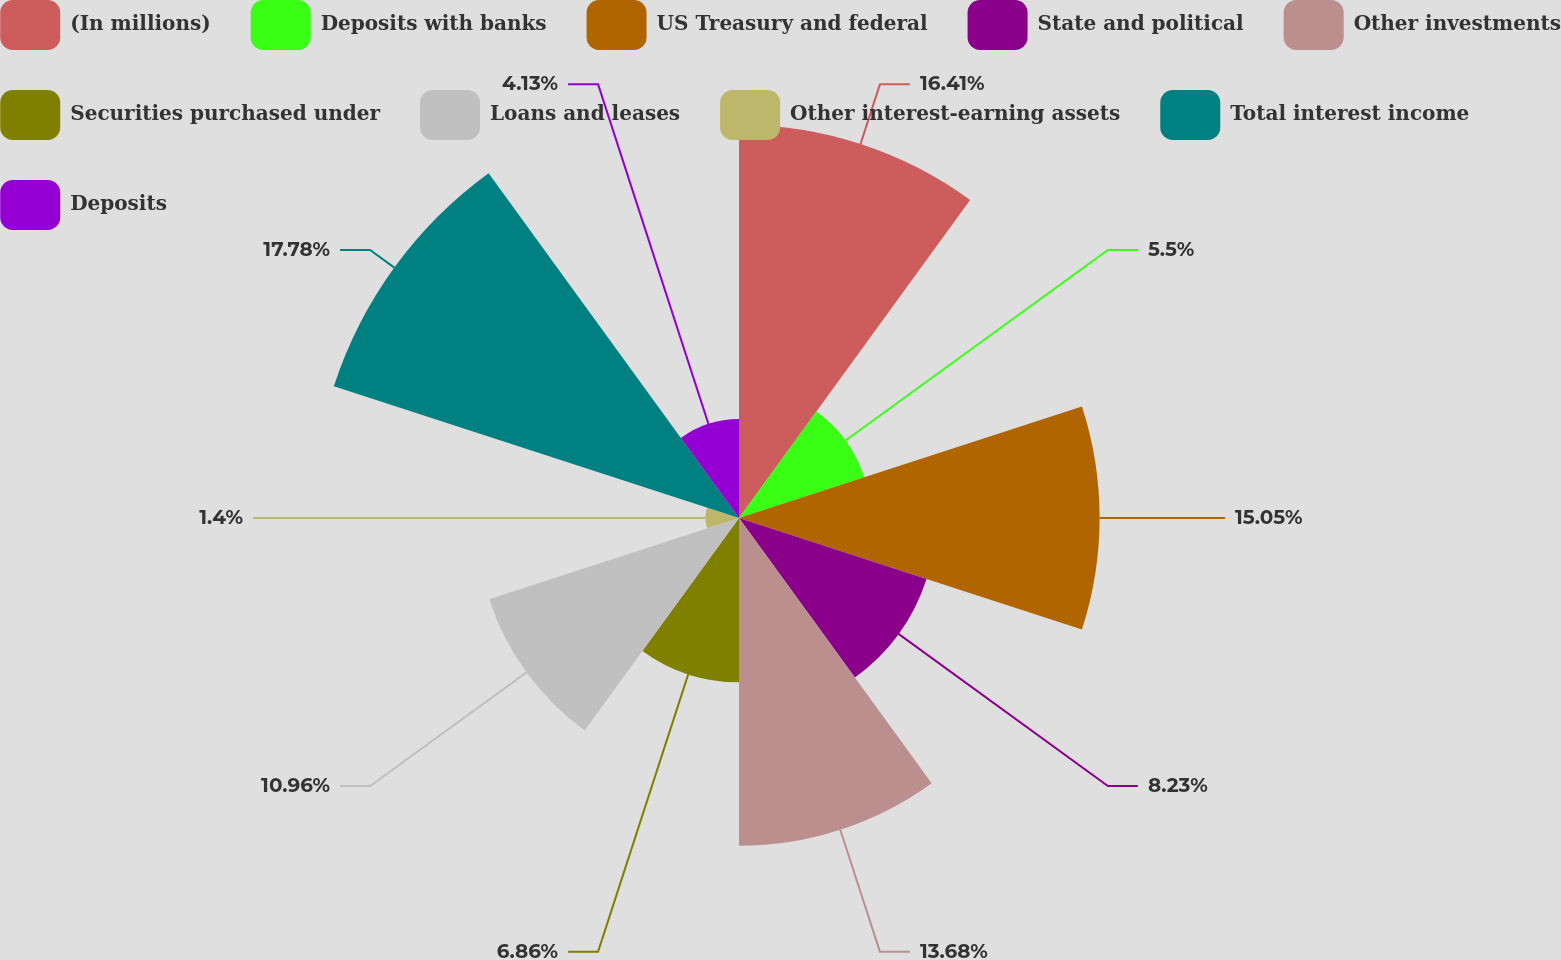Convert chart. <chart><loc_0><loc_0><loc_500><loc_500><pie_chart><fcel>(In millions)<fcel>Deposits with banks<fcel>US Treasury and federal<fcel>State and political<fcel>Other investments<fcel>Securities purchased under<fcel>Loans and leases<fcel>Other interest-earning assets<fcel>Total interest income<fcel>Deposits<nl><fcel>16.41%<fcel>5.5%<fcel>15.05%<fcel>8.23%<fcel>13.68%<fcel>6.86%<fcel>10.96%<fcel>1.4%<fcel>17.78%<fcel>4.13%<nl></chart> 